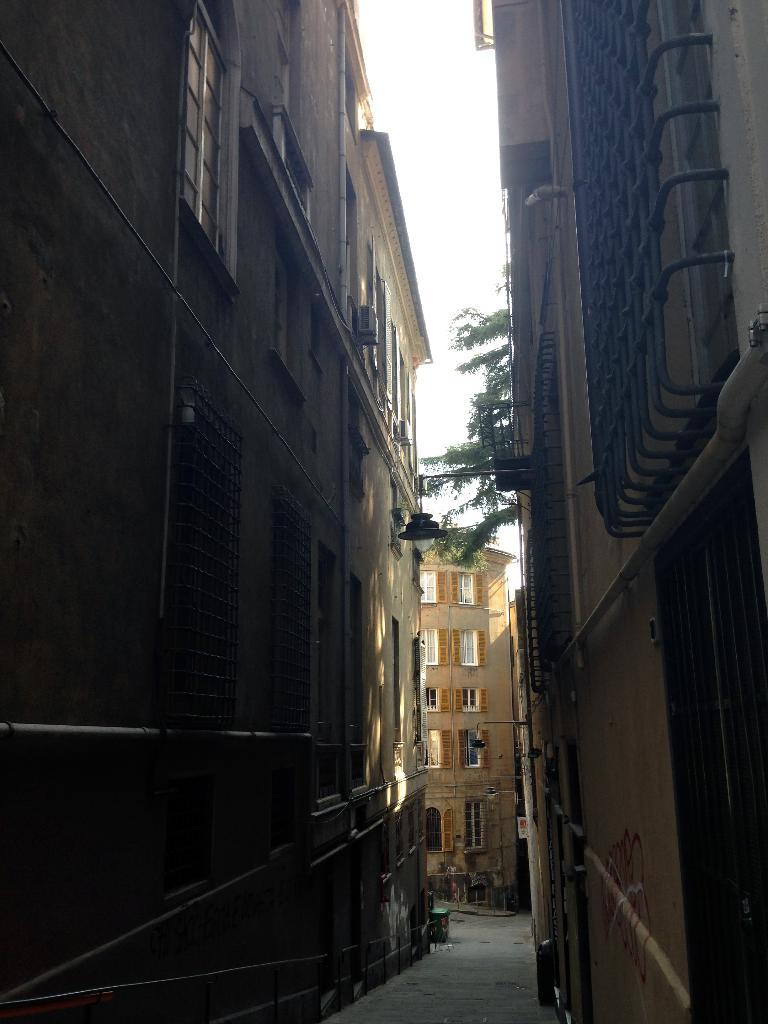What can be seen on both sides of the image? There are buildings on both sides of the image. What type of natural elements are present in the image? There are trees in the background of the image. What is visible in the background of the image? The sky is visible in the background of the image. What type of holiday is being celebrated in the image? There is no indication of a holiday being celebrated in the image. Can you describe the plantation in the image? There is no plantation present in the image. 